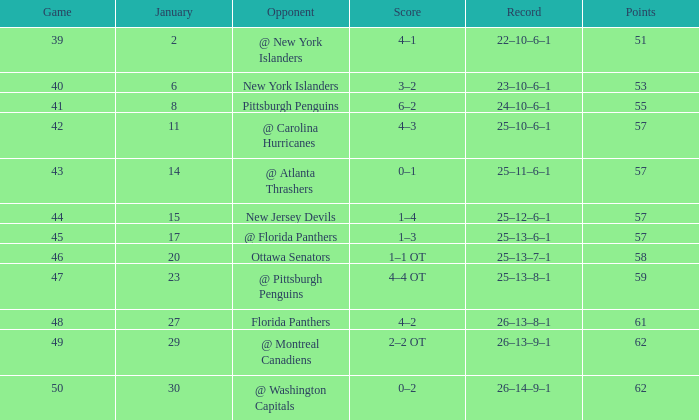Would you mind parsing the complete table? {'header': ['Game', 'January', 'Opponent', 'Score', 'Record', 'Points'], 'rows': [['39', '2', '@ New York Islanders', '4–1', '22–10–6–1', '51'], ['40', '6', 'New York Islanders', '3–2', '23–10–6–1', '53'], ['41', '8', 'Pittsburgh Penguins', '6–2', '24–10–6–1', '55'], ['42', '11', '@ Carolina Hurricanes', '4–3', '25–10–6–1', '57'], ['43', '14', '@ Atlanta Thrashers', '0–1', '25–11–6–1', '57'], ['44', '15', 'New Jersey Devils', '1–4', '25–12–6–1', '57'], ['45', '17', '@ Florida Panthers', '1–3', '25–13–6–1', '57'], ['46', '20', 'Ottawa Senators', '1–1 OT', '25–13–7–1', '58'], ['47', '23', '@ Pittsburgh Penguins', '4–4 OT', '25–13–8–1', '59'], ['48', '27', 'Florida Panthers', '4–2', '26–13–8–1', '61'], ['49', '29', '@ Montreal Canadiens', '2–2 OT', '26–13–9–1', '62'], ['50', '30', '@ Washington Capitals', '0–2', '26–14–9–1', '62']]} What opponent has an average less than 62 and a january average less than 6 @ New York Islanders. 